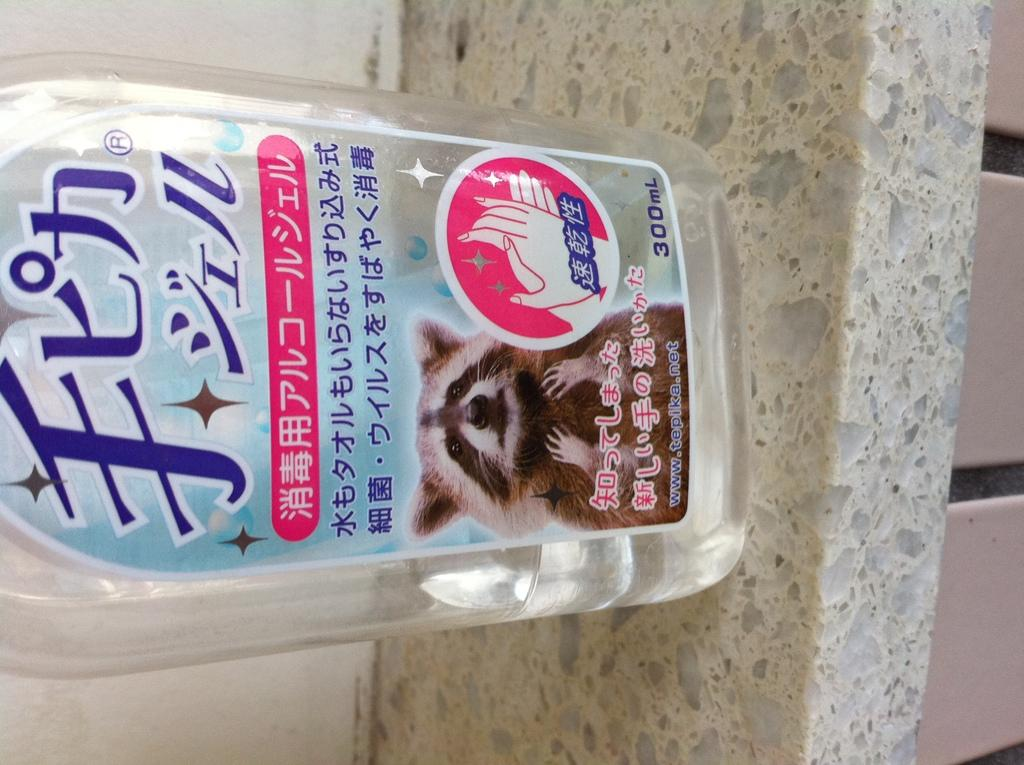What object can be seen in the image? There is a bottle in the image. Where is the bottle located? The bottle is on a shelf. What type of glue is being used to attach the substance to the class in the image? There is no glue, substance, or class present in the image; it only features a bottle on a shelf. 